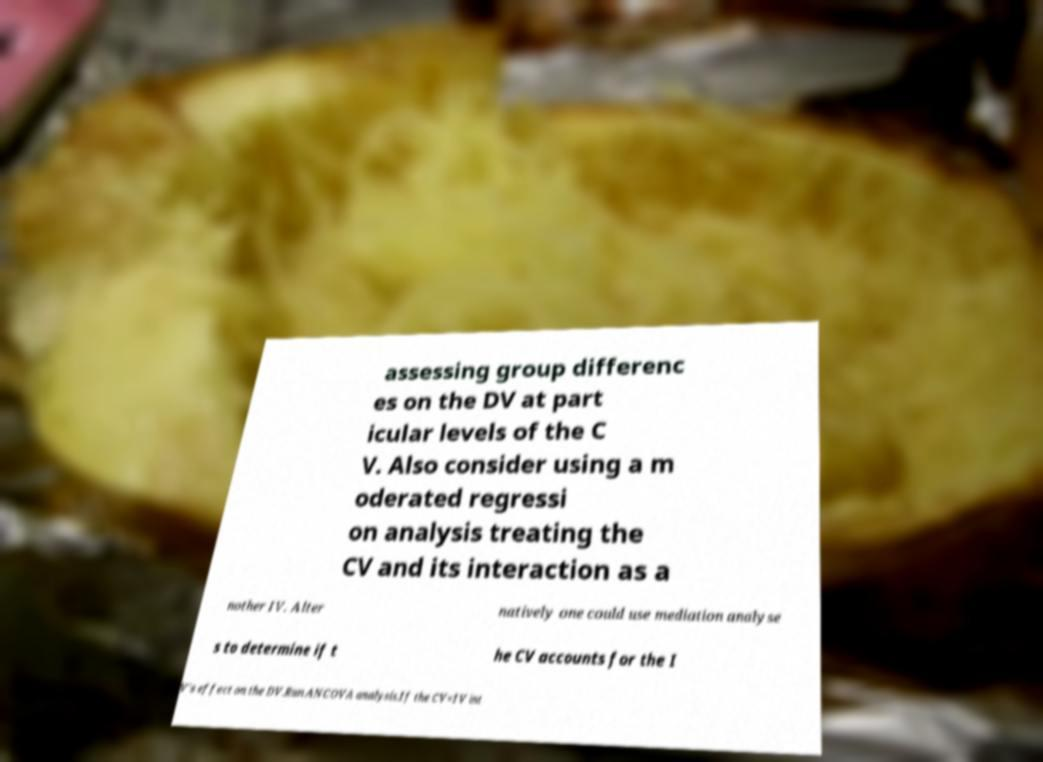There's text embedded in this image that I need extracted. Can you transcribe it verbatim? assessing group differenc es on the DV at part icular levels of the C V. Also consider using a m oderated regressi on analysis treating the CV and its interaction as a nother IV. Alter natively one could use mediation analyse s to determine if t he CV accounts for the I V's effect on the DV.Run ANCOVA analysis.If the CV×IV int 